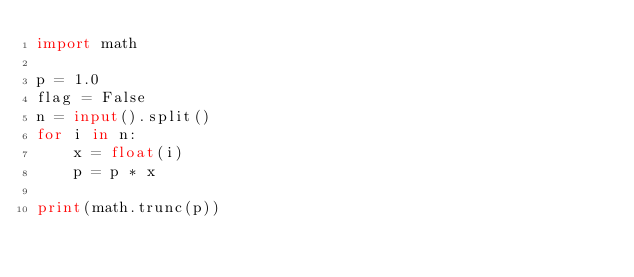Convert code to text. <code><loc_0><loc_0><loc_500><loc_500><_Python_>import math

p = 1.0
flag = False
n = input().split()
for i in n:
    x = float(i)
    p = p * x

print(math.trunc(p))
</code> 